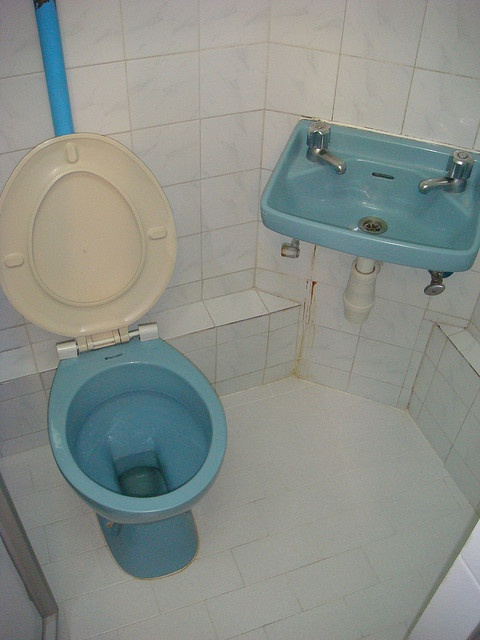Describe the objects in this image and their specific colors. I can see toilet in gray, tan, and teal tones and sink in gray and teal tones in this image. 